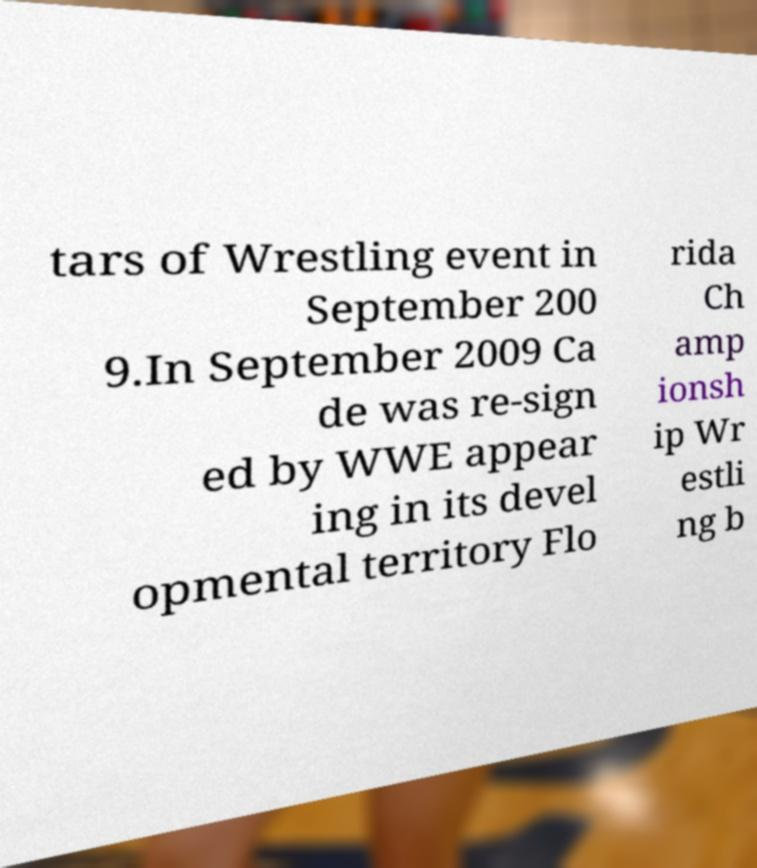What messages or text are displayed in this image? I need them in a readable, typed format. tars of Wrestling event in September 200 9.In September 2009 Ca de was re-sign ed by WWE appear ing in its devel opmental territory Flo rida Ch amp ionsh ip Wr estli ng b 